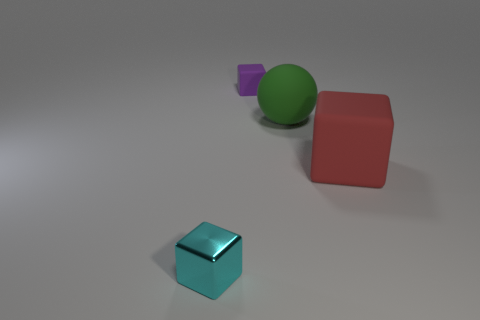Is the shape of the tiny cyan metallic object the same as the large green matte thing?
Your answer should be very brief. No. Is there a purple cube that has the same material as the large sphere?
Your response must be concise. Yes. There is a tiny thing right of the shiny thing; is there a small block that is in front of it?
Ensure brevity in your answer.  Yes. Does the rubber block to the right of the purple thing have the same size as the tiny cyan block?
Give a very brief answer. No. What size is the metallic thing?
Give a very brief answer. Small. Are there any other tiny things that have the same color as the tiny matte thing?
Keep it short and to the point. No. What number of tiny things are either red things or purple rubber blocks?
Offer a terse response. 1. There is a cube that is in front of the green ball and on the right side of the shiny object; how big is it?
Keep it short and to the point. Large. There is a red matte cube; how many tiny purple matte things are in front of it?
Ensure brevity in your answer.  0. The thing that is left of the large rubber ball and on the right side of the cyan thing has what shape?
Your answer should be compact. Cube. 